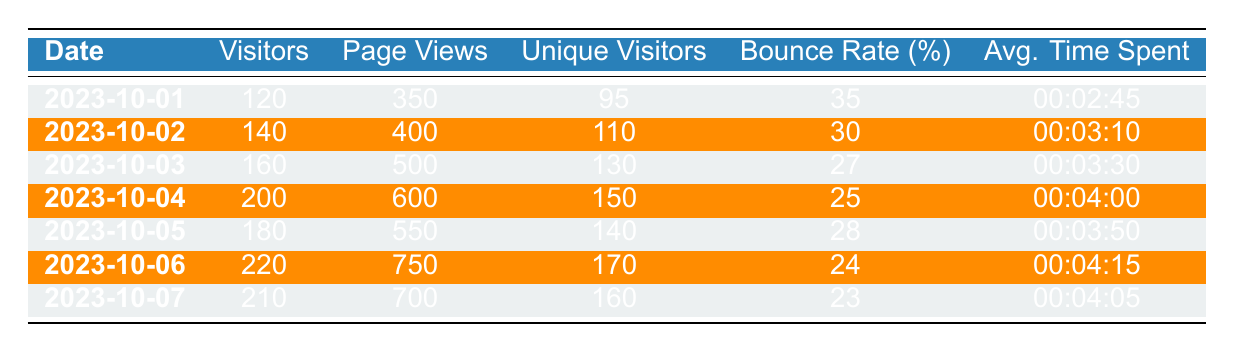What was the total number of visitors over the seven days? To find the total number of visitors, we need to sum the visitors for each day: 120 + 140 + 160 + 200 + 180 + 220 + 210 = 1,330.
Answer: 1,330 Which day had the highest average time spent? By comparing the average time spent for each day, we see that the highest value is for 2023-10-06, which is 00:04:15.
Answer: 2023-10-06 Was the bounce rate on 2023-10-04 lower than on 2023-10-02? The bounce rate for 2023-10-04 is 25% and for 2023-10-02 is 30%. Since 25% is less than 30%, the bounce rate on 2023-10-04 was indeed lower.
Answer: Yes What was the average number of unique visitors per day over the week? To calculate the average unique visitors, sum the unique visitors: 95 + 110 + 130 + 150 + 140 + 170 + 160 = 1,015. Then divide by the number of days (7): 1,015 / 7 = approximately 145.
Answer: 145 Is it true that the page views were consistently increasing from the start to the end of the week? Comparing each day's page views: 350, 400, 500, 600, 550, 750, 700 shows that the values do not consistently increase, as 550 is less than 600.
Answer: No Which date had the smallest number of visitors and what was that number? Looking through the visitors column, the smallest number is found on 2023-10-01 with 120 visitors.
Answer: 2023-10-01, 120 What was the difference in page views between the highest and lowest days? The highest page views are on 2023-10-06 with 750 and the lowest on 2023-10-01 with 350. The difference is 750 - 350 = 400.
Answer: 400 What was the total bounce rate for the entire week? The bounce rates for each day are: 35, 30, 27, 25, 28, 24, and 23; these cannot be added directly since they are percentages. Instead, individual percentages will not provide a total bounce rate as we lack total visitors for that calculation.
Answer: N/A 